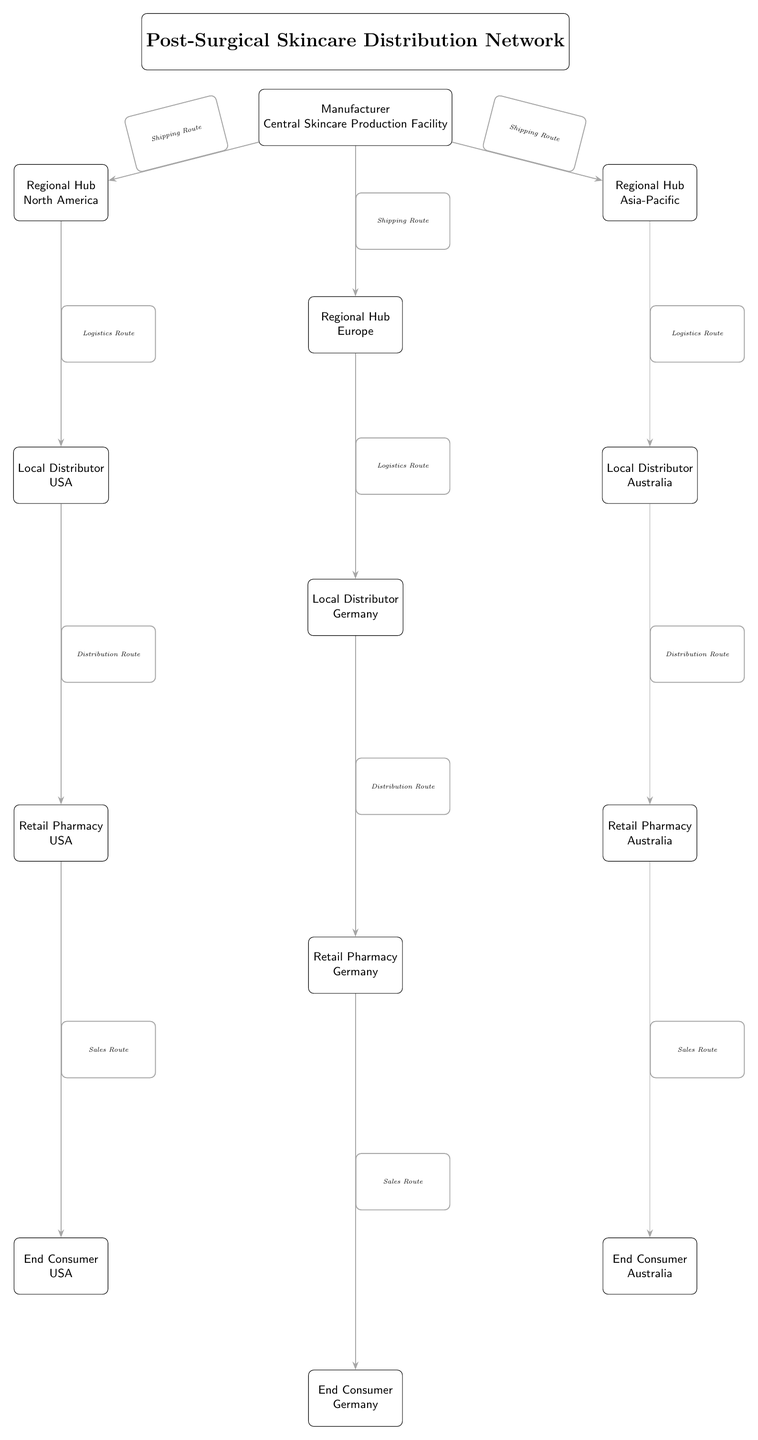What is the central node of the diagram? The central node is the "Central Skincare Production Facility," which is the primary manufacturer responsible for producing the post-surgical skincare products.
Answer: Central Skincare Production Facility How many regional hubs are displayed in the diagram? There are three regional hubs in the diagram: North America, Europe, and Asia-Pacific, each of which serves as a distribution point for local distributors.
Answer: 3 Which local distributor is linked to the Regional Hub in Europe? The local distributor linked to the Regional Hub in Europe is "Germany," which is responsible for distribution within that region.
Answer: Germany What type of route connects the Central Skincare Production Facility to the North America hub? The type of route that connects the Central Skincare Production Facility to the North America hub is a shipping route, indicating the means of transportation used for moving products to that hub.
Answer: Shipping Route Who is the end consumer linked to the Retail Pharmacy in Australia? The end consumer linked to the Retail Pharmacy in Australia is simply referred to as "End Consumer," indicating the final recipient of the product in that market.
Answer: End Consumer How many sales routes are illustrated in the diagram? There are three sales routes illustrated: one each leading from the Retail Pharmacies in the USA, Germany, and Australia to their respective end consumers.
Answer: 3 What is the relationship between the Local Distributor in the USA and the Retail Pharmacy in the USA? The relationship is a distribution route where the Local Distributor in the USA is responsible for supplying products to the Retail Pharmacy, which then sells to the end consumer.
Answer: Distribution Route Which regional hub is located to the right of the Central Skincare Production Facility? The regional hub located to the right of the Central Skincare Production Facility is "Asia-Pacific," which serves as an important market for post-surgical skincare products.
Answer: Asia-Pacific What level in the hierarchy is the Local Distributor in Germany? The Local Distributor in Germany is at level 2 in the hierarchy, directly beneath the Regional Hub for Europe, indicating it is a local link in the distribution network.
Answer: Level 2 